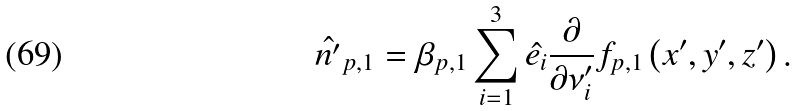<formula> <loc_0><loc_0><loc_500><loc_500>\hat { n ^ { \prime } } _ { p , 1 } & = \beta _ { p , 1 } \sum _ { i = 1 } ^ { 3 } \hat { e _ { i } } \frac { \partial } { \partial \nu ^ { \prime } _ { i } } f _ { p , 1 } \left ( x ^ { \prime } , y ^ { \prime } , z ^ { \prime } \right ) .</formula> 